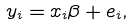Convert formula to latex. <formula><loc_0><loc_0><loc_500><loc_500>y _ { i } = x _ { i } \beta + e _ { i } ,</formula> 